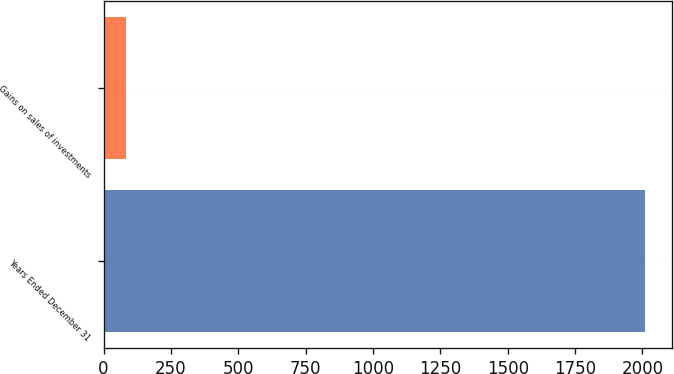<chart> <loc_0><loc_0><loc_500><loc_500><bar_chart><fcel>Years Ended December 31<fcel>Gains on sales of investments<nl><fcel>2008<fcel>82<nl></chart> 